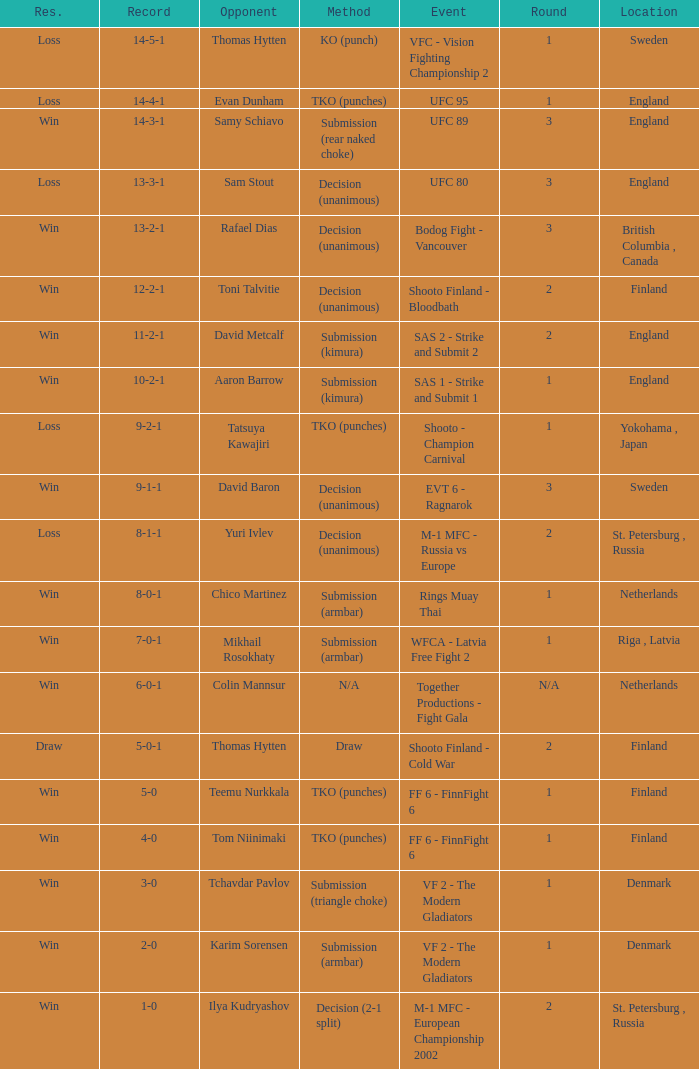Who was the opponent with a record of 14-4-1 and has a round of 1? Evan Dunham. 